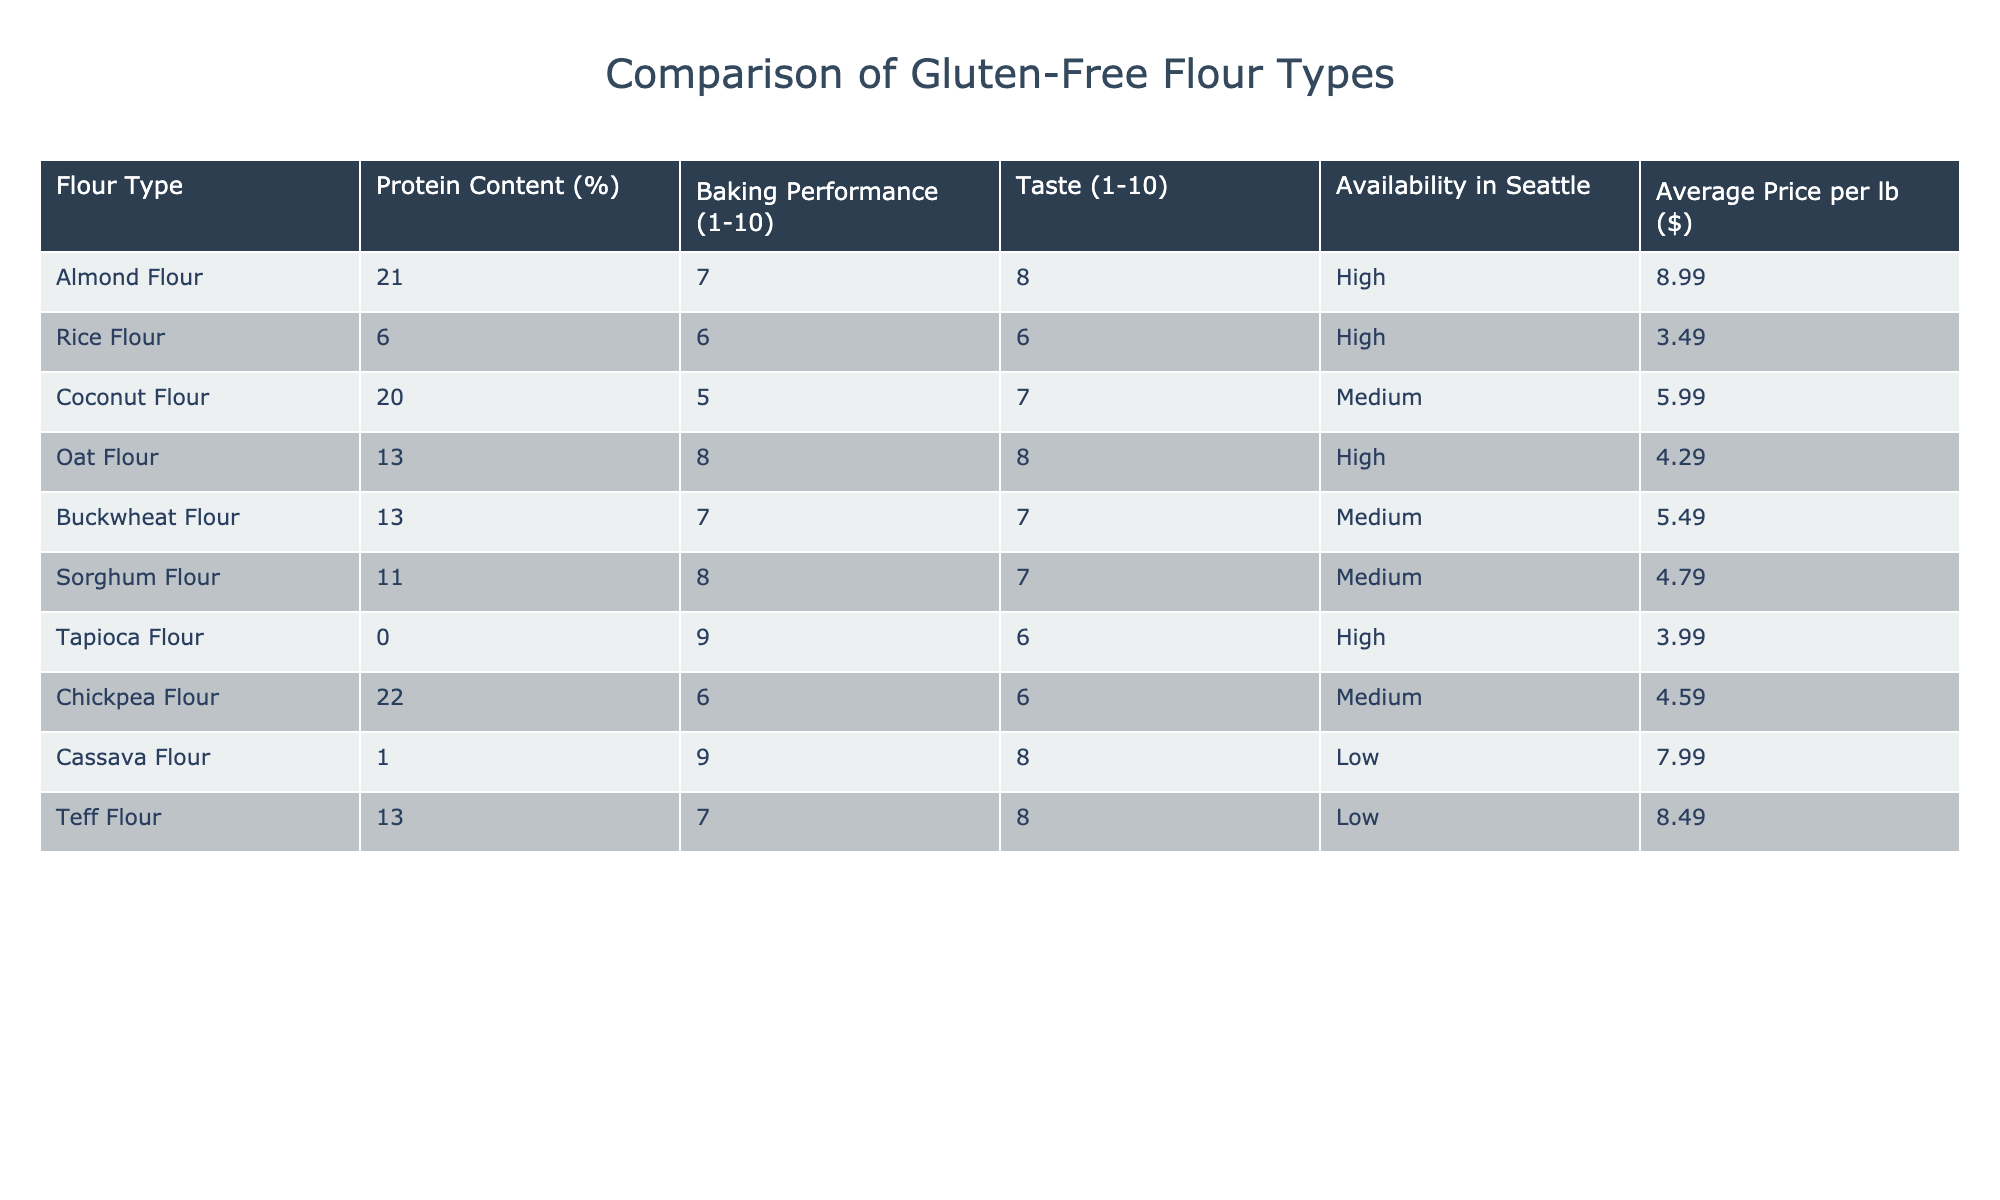What is the protein content of almond flour? The table lists the protein content for almond flour, which shows a value of 21%.
Answer: 21% Which flour has the highest baking performance score? By comparing the baking performance scores in the table, tapioca flour has the highest score of 9.
Answer: 9 What is the average price per pound of buckwheat flour? The table indicates that the average price per pound of buckwheat flour is $5.49.
Answer: $5.49 Is oat flour available in Seattle? The table categorizes oat flour's availability as "High," indicating it is commonly found in Seattle.
Answer: Yes Which flour type has the lowest protein content? By inspecting the protein content values, cassava flour has the lowest protein content at 1%.
Answer: 1% What is the difference in baking performance between chickpea flour and sorghum flour? The baking performance of chickpea flour is 6 and for sorghum flour is 8. The difference is 8 - 6 = 2.
Answer: 2 Which flour types have a taste score of 8? Oat flour, cassava flour, and almond flour all have a taste score of 8.
Answer: Oat flour, cassava flour, almond flour What is the combined baking performance score of coconut flour and rice flour? Coconut flour has a baking performance of 5 and rice flour has 6. Adding these, 5 + 6 = 11.
Answer: 11 Is the availability of coconut flour high? The availability of coconut flour is categorized as "Medium," so it is not high.
Answer: No Which flour has the highest protein content and what is its baking performance score? The flour with the highest protein content is chickpea flour at 22%, with a baking performance score of 6.
Answer: Chickpea flour, 6 What is the average taste score for all the flours listed? By adding the taste scores (8 + 6 + 7 + 8 + 7 + 7 + 6 + 6 + 8 + 8) = 69 and dividing by the number of flours (10), the average taste score is 6.9.
Answer: 6.9 What is the total average price of all the flour types? Summing the prices (8.99 + 3.49 + 5.99 + 4.29 + 5.49 + 4.79 + 3.99 + 4.59 + 7.99 + 8.49) = 56.50, and dividing by 10 gives an average price of $5.65.
Answer: $5.65 